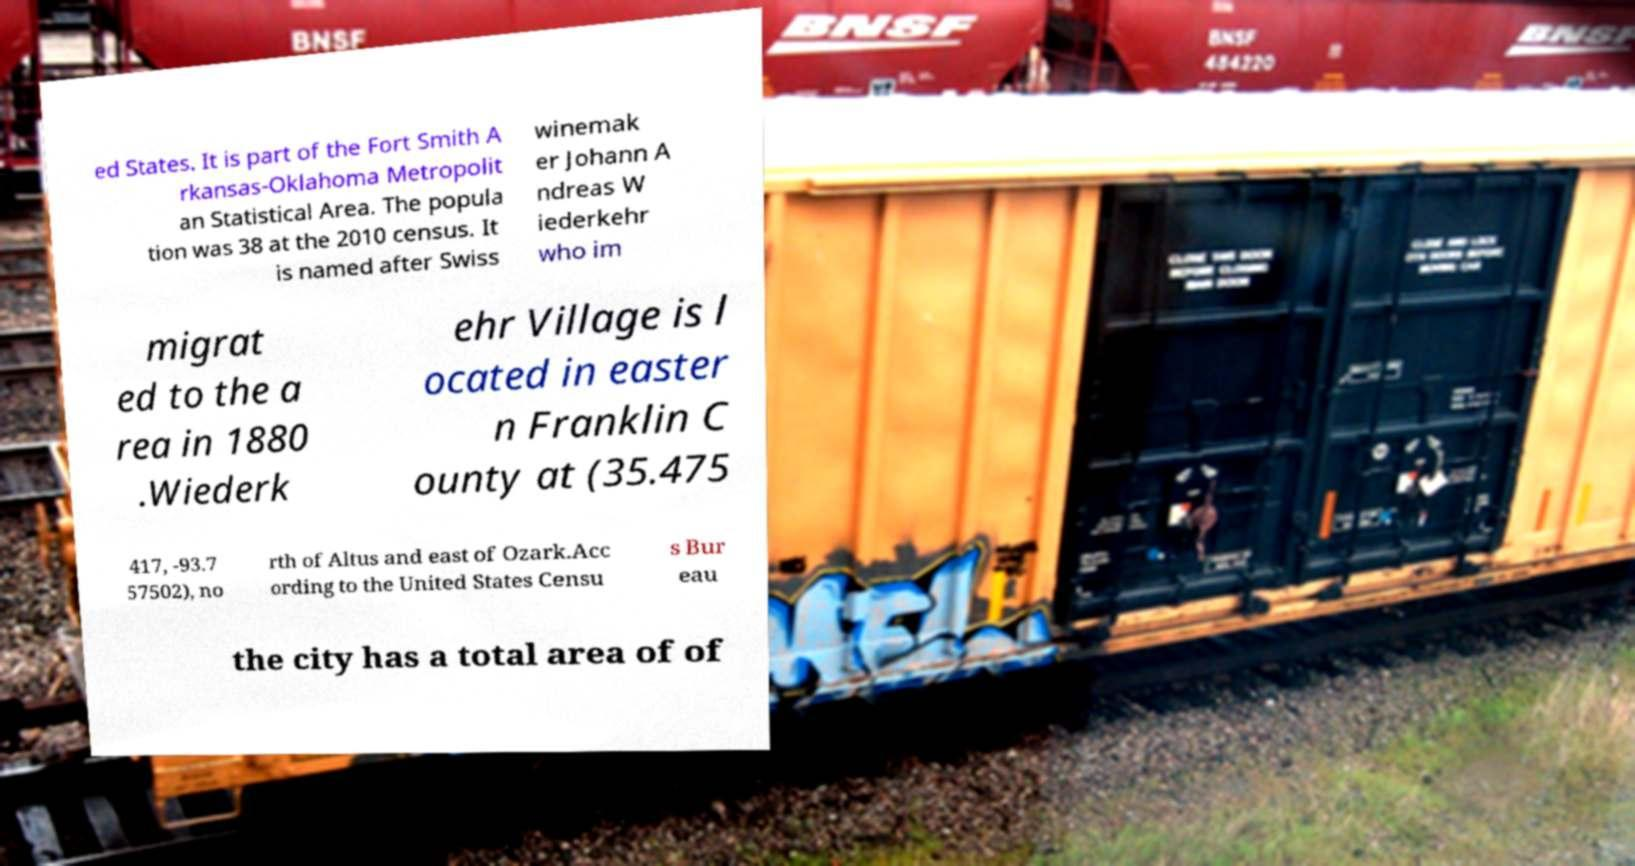Please read and relay the text visible in this image. What does it say? ed States. It is part of the Fort Smith A rkansas-Oklahoma Metropolit an Statistical Area. The popula tion was 38 at the 2010 census. It is named after Swiss winemak er Johann A ndreas W iederkehr who im migrat ed to the a rea in 1880 .Wiederk ehr Village is l ocated in easter n Franklin C ounty at (35.475 417, -93.7 57502), no rth of Altus and east of Ozark.Acc ording to the United States Censu s Bur eau the city has a total area of of 